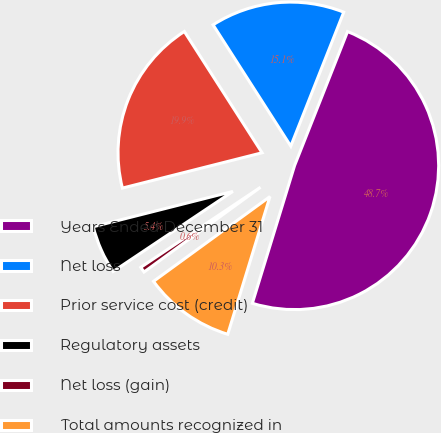Convert chart to OTSL. <chart><loc_0><loc_0><loc_500><loc_500><pie_chart><fcel>Years Ended December 31<fcel>Net loss<fcel>Prior service cost (credit)<fcel>Regulatory assets<fcel>Net loss (gain)<fcel>Total amounts recognized in<nl><fcel>48.74%<fcel>15.06%<fcel>19.87%<fcel>5.44%<fcel>0.63%<fcel>10.25%<nl></chart> 